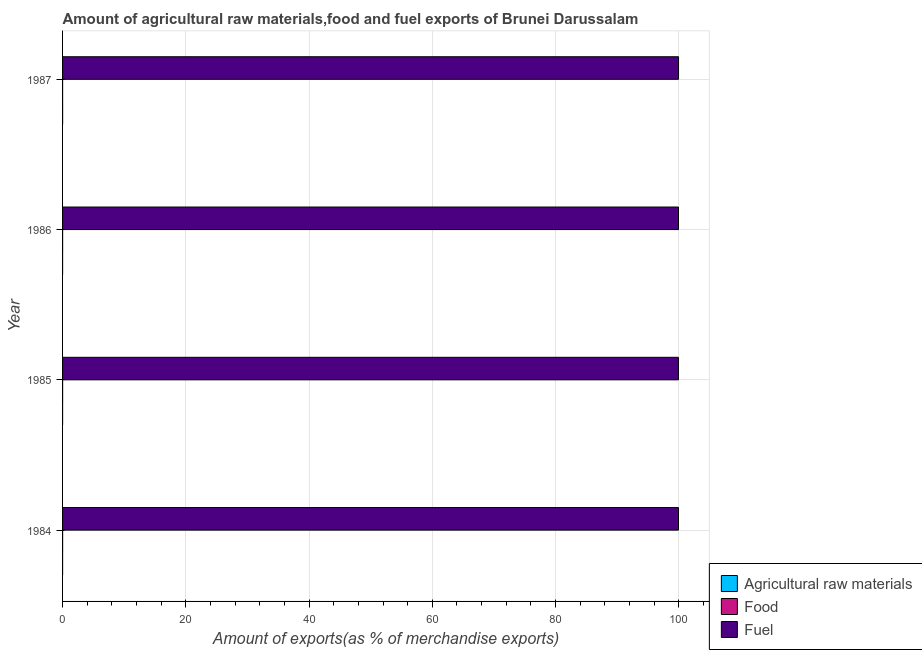How many different coloured bars are there?
Offer a very short reply. 3. Are the number of bars on each tick of the Y-axis equal?
Ensure brevity in your answer.  Yes. How many bars are there on the 1st tick from the top?
Provide a succinct answer. 3. How many bars are there on the 3rd tick from the bottom?
Provide a succinct answer. 3. What is the label of the 1st group of bars from the top?
Your response must be concise. 1987. What is the percentage of raw materials exports in 1987?
Your answer should be very brief. 0.01. Across all years, what is the maximum percentage of food exports?
Offer a very short reply. 0.01. Across all years, what is the minimum percentage of fuel exports?
Give a very brief answer. 99.93. What is the total percentage of fuel exports in the graph?
Offer a terse response. 399.78. What is the difference between the percentage of fuel exports in 1984 and that in 1986?
Provide a succinct answer. -0. What is the difference between the percentage of food exports in 1985 and the percentage of raw materials exports in 1986?
Ensure brevity in your answer.  0.01. What is the average percentage of food exports per year?
Your response must be concise. 0.01. In the year 1985, what is the difference between the percentage of fuel exports and percentage of food exports?
Your answer should be compact. 99.93. What is the ratio of the percentage of food exports in 1986 to that in 1987?
Ensure brevity in your answer.  1.69. Is the percentage of food exports in 1984 less than that in 1985?
Your answer should be compact. No. What is the difference between the highest and the second highest percentage of raw materials exports?
Provide a short and direct response. 0.01. What is the difference between the highest and the lowest percentage of fuel exports?
Give a very brief answer. 0.02. In how many years, is the percentage of food exports greater than the average percentage of food exports taken over all years?
Your answer should be compact. 3. What does the 3rd bar from the top in 1987 represents?
Offer a very short reply. Agricultural raw materials. What does the 2nd bar from the bottom in 1986 represents?
Your response must be concise. Food. Is it the case that in every year, the sum of the percentage of raw materials exports and percentage of food exports is greater than the percentage of fuel exports?
Your response must be concise. No. Does the graph contain any zero values?
Make the answer very short. No. Does the graph contain grids?
Offer a terse response. Yes. How many legend labels are there?
Your answer should be compact. 3. How are the legend labels stacked?
Your response must be concise. Vertical. What is the title of the graph?
Provide a short and direct response. Amount of agricultural raw materials,food and fuel exports of Brunei Darussalam. What is the label or title of the X-axis?
Make the answer very short. Amount of exports(as % of merchandise exports). What is the Amount of exports(as % of merchandise exports) of Agricultural raw materials in 1984?
Provide a short and direct response. 0. What is the Amount of exports(as % of merchandise exports) in Food in 1984?
Keep it short and to the point. 0.01. What is the Amount of exports(as % of merchandise exports) in Fuel in 1984?
Your response must be concise. 99.94. What is the Amount of exports(as % of merchandise exports) in Agricultural raw materials in 1985?
Your response must be concise. 0. What is the Amount of exports(as % of merchandise exports) of Food in 1985?
Offer a very short reply. 0.01. What is the Amount of exports(as % of merchandise exports) of Fuel in 1985?
Your answer should be very brief. 99.93. What is the Amount of exports(as % of merchandise exports) of Agricultural raw materials in 1986?
Provide a succinct answer. 0. What is the Amount of exports(as % of merchandise exports) in Food in 1986?
Offer a very short reply. 0.01. What is the Amount of exports(as % of merchandise exports) of Fuel in 1986?
Keep it short and to the point. 99.95. What is the Amount of exports(as % of merchandise exports) in Agricultural raw materials in 1987?
Give a very brief answer. 0.01. What is the Amount of exports(as % of merchandise exports) of Food in 1987?
Provide a succinct answer. 0. What is the Amount of exports(as % of merchandise exports) in Fuel in 1987?
Your answer should be compact. 99.95. Across all years, what is the maximum Amount of exports(as % of merchandise exports) in Agricultural raw materials?
Your answer should be compact. 0.01. Across all years, what is the maximum Amount of exports(as % of merchandise exports) of Food?
Provide a short and direct response. 0.01. Across all years, what is the maximum Amount of exports(as % of merchandise exports) of Fuel?
Offer a terse response. 99.95. Across all years, what is the minimum Amount of exports(as % of merchandise exports) of Agricultural raw materials?
Your response must be concise. 0. Across all years, what is the minimum Amount of exports(as % of merchandise exports) of Food?
Your response must be concise. 0. Across all years, what is the minimum Amount of exports(as % of merchandise exports) in Fuel?
Offer a very short reply. 99.93. What is the total Amount of exports(as % of merchandise exports) in Agricultural raw materials in the graph?
Your answer should be very brief. 0.01. What is the total Amount of exports(as % of merchandise exports) of Food in the graph?
Offer a terse response. 0.02. What is the total Amount of exports(as % of merchandise exports) of Fuel in the graph?
Offer a terse response. 399.78. What is the difference between the Amount of exports(as % of merchandise exports) in Agricultural raw materials in 1984 and that in 1985?
Offer a terse response. -0. What is the difference between the Amount of exports(as % of merchandise exports) in Food in 1984 and that in 1985?
Your answer should be very brief. 0. What is the difference between the Amount of exports(as % of merchandise exports) in Fuel in 1984 and that in 1985?
Offer a terse response. 0.01. What is the difference between the Amount of exports(as % of merchandise exports) in Agricultural raw materials in 1984 and that in 1986?
Provide a succinct answer. -0. What is the difference between the Amount of exports(as % of merchandise exports) in Food in 1984 and that in 1986?
Make the answer very short. 0. What is the difference between the Amount of exports(as % of merchandise exports) of Fuel in 1984 and that in 1986?
Offer a very short reply. -0. What is the difference between the Amount of exports(as % of merchandise exports) in Agricultural raw materials in 1984 and that in 1987?
Provide a succinct answer. -0.01. What is the difference between the Amount of exports(as % of merchandise exports) in Food in 1984 and that in 1987?
Your response must be concise. 0. What is the difference between the Amount of exports(as % of merchandise exports) in Fuel in 1984 and that in 1987?
Give a very brief answer. -0.01. What is the difference between the Amount of exports(as % of merchandise exports) of Fuel in 1985 and that in 1986?
Provide a succinct answer. -0.01. What is the difference between the Amount of exports(as % of merchandise exports) of Agricultural raw materials in 1985 and that in 1987?
Provide a succinct answer. -0.01. What is the difference between the Amount of exports(as % of merchandise exports) of Food in 1985 and that in 1987?
Offer a terse response. 0. What is the difference between the Amount of exports(as % of merchandise exports) of Fuel in 1985 and that in 1987?
Offer a terse response. -0.02. What is the difference between the Amount of exports(as % of merchandise exports) in Agricultural raw materials in 1986 and that in 1987?
Your answer should be very brief. -0.01. What is the difference between the Amount of exports(as % of merchandise exports) in Food in 1986 and that in 1987?
Your response must be concise. 0. What is the difference between the Amount of exports(as % of merchandise exports) in Fuel in 1986 and that in 1987?
Ensure brevity in your answer.  -0.01. What is the difference between the Amount of exports(as % of merchandise exports) in Agricultural raw materials in 1984 and the Amount of exports(as % of merchandise exports) in Food in 1985?
Your answer should be compact. -0.01. What is the difference between the Amount of exports(as % of merchandise exports) of Agricultural raw materials in 1984 and the Amount of exports(as % of merchandise exports) of Fuel in 1985?
Your answer should be very brief. -99.93. What is the difference between the Amount of exports(as % of merchandise exports) in Food in 1984 and the Amount of exports(as % of merchandise exports) in Fuel in 1985?
Provide a short and direct response. -99.93. What is the difference between the Amount of exports(as % of merchandise exports) of Agricultural raw materials in 1984 and the Amount of exports(as % of merchandise exports) of Food in 1986?
Your answer should be compact. -0.01. What is the difference between the Amount of exports(as % of merchandise exports) of Agricultural raw materials in 1984 and the Amount of exports(as % of merchandise exports) of Fuel in 1986?
Provide a short and direct response. -99.95. What is the difference between the Amount of exports(as % of merchandise exports) of Food in 1984 and the Amount of exports(as % of merchandise exports) of Fuel in 1986?
Offer a very short reply. -99.94. What is the difference between the Amount of exports(as % of merchandise exports) in Agricultural raw materials in 1984 and the Amount of exports(as % of merchandise exports) in Food in 1987?
Provide a succinct answer. -0. What is the difference between the Amount of exports(as % of merchandise exports) in Agricultural raw materials in 1984 and the Amount of exports(as % of merchandise exports) in Fuel in 1987?
Your answer should be compact. -99.95. What is the difference between the Amount of exports(as % of merchandise exports) of Food in 1984 and the Amount of exports(as % of merchandise exports) of Fuel in 1987?
Ensure brevity in your answer.  -99.95. What is the difference between the Amount of exports(as % of merchandise exports) in Agricultural raw materials in 1985 and the Amount of exports(as % of merchandise exports) in Food in 1986?
Your answer should be very brief. -0.01. What is the difference between the Amount of exports(as % of merchandise exports) in Agricultural raw materials in 1985 and the Amount of exports(as % of merchandise exports) in Fuel in 1986?
Ensure brevity in your answer.  -99.95. What is the difference between the Amount of exports(as % of merchandise exports) in Food in 1985 and the Amount of exports(as % of merchandise exports) in Fuel in 1986?
Your response must be concise. -99.94. What is the difference between the Amount of exports(as % of merchandise exports) of Agricultural raw materials in 1985 and the Amount of exports(as % of merchandise exports) of Food in 1987?
Provide a succinct answer. -0. What is the difference between the Amount of exports(as % of merchandise exports) in Agricultural raw materials in 1985 and the Amount of exports(as % of merchandise exports) in Fuel in 1987?
Provide a succinct answer. -99.95. What is the difference between the Amount of exports(as % of merchandise exports) of Food in 1985 and the Amount of exports(as % of merchandise exports) of Fuel in 1987?
Make the answer very short. -99.95. What is the difference between the Amount of exports(as % of merchandise exports) of Agricultural raw materials in 1986 and the Amount of exports(as % of merchandise exports) of Food in 1987?
Make the answer very short. -0. What is the difference between the Amount of exports(as % of merchandise exports) of Agricultural raw materials in 1986 and the Amount of exports(as % of merchandise exports) of Fuel in 1987?
Your answer should be compact. -99.95. What is the difference between the Amount of exports(as % of merchandise exports) in Food in 1986 and the Amount of exports(as % of merchandise exports) in Fuel in 1987?
Provide a succinct answer. -99.95. What is the average Amount of exports(as % of merchandise exports) of Agricultural raw materials per year?
Keep it short and to the point. 0. What is the average Amount of exports(as % of merchandise exports) in Food per year?
Provide a succinct answer. 0.01. What is the average Amount of exports(as % of merchandise exports) of Fuel per year?
Offer a terse response. 99.94. In the year 1984, what is the difference between the Amount of exports(as % of merchandise exports) of Agricultural raw materials and Amount of exports(as % of merchandise exports) of Food?
Keep it short and to the point. -0.01. In the year 1984, what is the difference between the Amount of exports(as % of merchandise exports) in Agricultural raw materials and Amount of exports(as % of merchandise exports) in Fuel?
Ensure brevity in your answer.  -99.94. In the year 1984, what is the difference between the Amount of exports(as % of merchandise exports) of Food and Amount of exports(as % of merchandise exports) of Fuel?
Offer a very short reply. -99.94. In the year 1985, what is the difference between the Amount of exports(as % of merchandise exports) of Agricultural raw materials and Amount of exports(as % of merchandise exports) of Food?
Keep it short and to the point. -0.01. In the year 1985, what is the difference between the Amount of exports(as % of merchandise exports) in Agricultural raw materials and Amount of exports(as % of merchandise exports) in Fuel?
Keep it short and to the point. -99.93. In the year 1985, what is the difference between the Amount of exports(as % of merchandise exports) in Food and Amount of exports(as % of merchandise exports) in Fuel?
Provide a short and direct response. -99.93. In the year 1986, what is the difference between the Amount of exports(as % of merchandise exports) in Agricultural raw materials and Amount of exports(as % of merchandise exports) in Food?
Your answer should be compact. -0.01. In the year 1986, what is the difference between the Amount of exports(as % of merchandise exports) in Agricultural raw materials and Amount of exports(as % of merchandise exports) in Fuel?
Make the answer very short. -99.95. In the year 1986, what is the difference between the Amount of exports(as % of merchandise exports) of Food and Amount of exports(as % of merchandise exports) of Fuel?
Provide a short and direct response. -99.94. In the year 1987, what is the difference between the Amount of exports(as % of merchandise exports) of Agricultural raw materials and Amount of exports(as % of merchandise exports) of Food?
Offer a very short reply. 0. In the year 1987, what is the difference between the Amount of exports(as % of merchandise exports) in Agricultural raw materials and Amount of exports(as % of merchandise exports) in Fuel?
Your response must be concise. -99.95. In the year 1987, what is the difference between the Amount of exports(as % of merchandise exports) in Food and Amount of exports(as % of merchandise exports) in Fuel?
Your answer should be compact. -99.95. What is the ratio of the Amount of exports(as % of merchandise exports) of Agricultural raw materials in 1984 to that in 1985?
Give a very brief answer. 0.79. What is the ratio of the Amount of exports(as % of merchandise exports) in Food in 1984 to that in 1985?
Give a very brief answer. 1.05. What is the ratio of the Amount of exports(as % of merchandise exports) of Agricultural raw materials in 1984 to that in 1986?
Offer a very short reply. 0.87. What is the ratio of the Amount of exports(as % of merchandise exports) of Food in 1984 to that in 1986?
Your answer should be very brief. 1.1. What is the ratio of the Amount of exports(as % of merchandise exports) in Agricultural raw materials in 1984 to that in 1987?
Provide a short and direct response. 0.13. What is the ratio of the Amount of exports(as % of merchandise exports) in Food in 1984 to that in 1987?
Keep it short and to the point. 1.86. What is the ratio of the Amount of exports(as % of merchandise exports) in Fuel in 1984 to that in 1987?
Your answer should be compact. 1. What is the ratio of the Amount of exports(as % of merchandise exports) of Agricultural raw materials in 1985 to that in 1986?
Make the answer very short. 1.1. What is the ratio of the Amount of exports(as % of merchandise exports) of Food in 1985 to that in 1986?
Offer a very short reply. 1.04. What is the ratio of the Amount of exports(as % of merchandise exports) of Fuel in 1985 to that in 1986?
Offer a very short reply. 1. What is the ratio of the Amount of exports(as % of merchandise exports) in Agricultural raw materials in 1985 to that in 1987?
Your response must be concise. 0.16. What is the ratio of the Amount of exports(as % of merchandise exports) in Food in 1985 to that in 1987?
Your response must be concise. 1.77. What is the ratio of the Amount of exports(as % of merchandise exports) of Fuel in 1985 to that in 1987?
Provide a short and direct response. 1. What is the ratio of the Amount of exports(as % of merchandise exports) in Agricultural raw materials in 1986 to that in 1987?
Your answer should be compact. 0.15. What is the ratio of the Amount of exports(as % of merchandise exports) of Food in 1986 to that in 1987?
Provide a succinct answer. 1.69. What is the ratio of the Amount of exports(as % of merchandise exports) of Fuel in 1986 to that in 1987?
Offer a very short reply. 1. What is the difference between the highest and the second highest Amount of exports(as % of merchandise exports) in Agricultural raw materials?
Your response must be concise. 0.01. What is the difference between the highest and the second highest Amount of exports(as % of merchandise exports) in Fuel?
Make the answer very short. 0.01. What is the difference between the highest and the lowest Amount of exports(as % of merchandise exports) of Agricultural raw materials?
Provide a short and direct response. 0.01. What is the difference between the highest and the lowest Amount of exports(as % of merchandise exports) in Food?
Your answer should be compact. 0. What is the difference between the highest and the lowest Amount of exports(as % of merchandise exports) of Fuel?
Your answer should be compact. 0.02. 